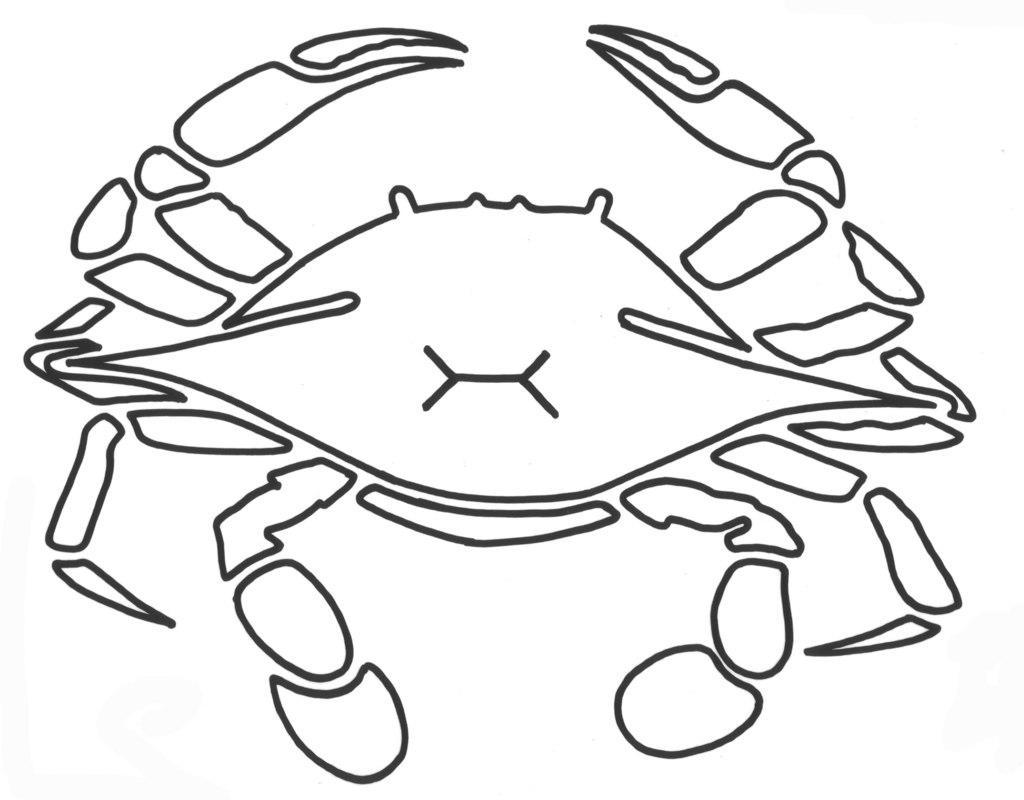Can you describe this image briefly? It is a sketch of a crab. 